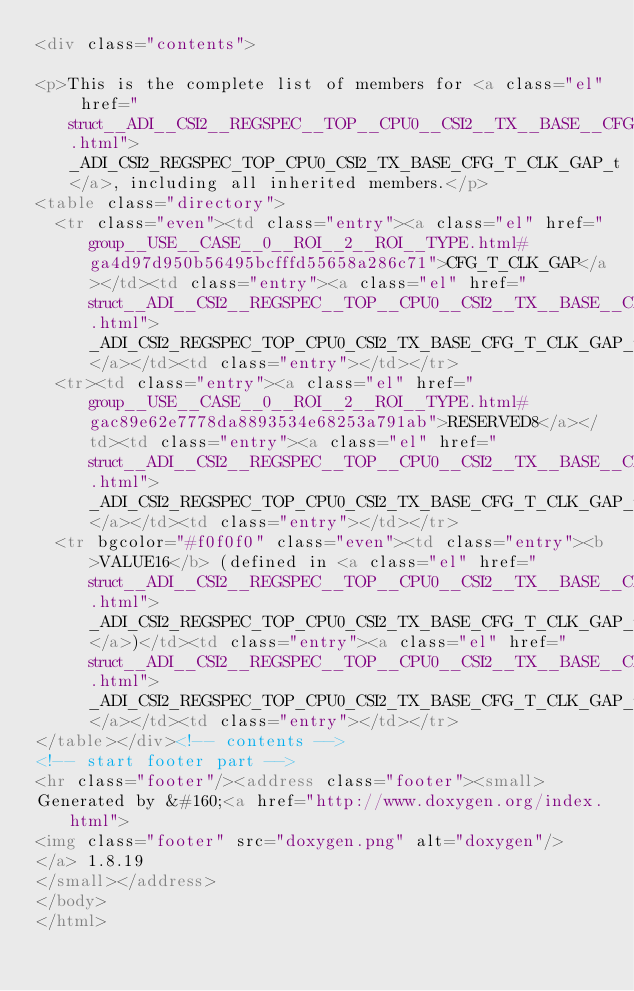Convert code to text. <code><loc_0><loc_0><loc_500><loc_500><_HTML_><div class="contents">

<p>This is the complete list of members for <a class="el" href="struct__ADI__CSI2__REGSPEC__TOP__CPU0__CSI2__TX__BASE__CFG__T__CLK__GAP__t.html">_ADI_CSI2_REGSPEC_TOP_CPU0_CSI2_TX_BASE_CFG_T_CLK_GAP_t</a>, including all inherited members.</p>
<table class="directory">
  <tr class="even"><td class="entry"><a class="el" href="group__USE__CASE__0__ROI__2__ROI__TYPE.html#ga4d97d950b56495bcfffd55658a286c71">CFG_T_CLK_GAP</a></td><td class="entry"><a class="el" href="struct__ADI__CSI2__REGSPEC__TOP__CPU0__CSI2__TX__BASE__CFG__T__CLK__GAP__t.html">_ADI_CSI2_REGSPEC_TOP_CPU0_CSI2_TX_BASE_CFG_T_CLK_GAP_t</a></td><td class="entry"></td></tr>
  <tr><td class="entry"><a class="el" href="group__USE__CASE__0__ROI__2__ROI__TYPE.html#gac89e62e7778da8893534e68253a791ab">RESERVED8</a></td><td class="entry"><a class="el" href="struct__ADI__CSI2__REGSPEC__TOP__CPU0__CSI2__TX__BASE__CFG__T__CLK__GAP__t.html">_ADI_CSI2_REGSPEC_TOP_CPU0_CSI2_TX_BASE_CFG_T_CLK_GAP_t</a></td><td class="entry"></td></tr>
  <tr bgcolor="#f0f0f0" class="even"><td class="entry"><b>VALUE16</b> (defined in <a class="el" href="struct__ADI__CSI2__REGSPEC__TOP__CPU0__CSI2__TX__BASE__CFG__T__CLK__GAP__t.html">_ADI_CSI2_REGSPEC_TOP_CPU0_CSI2_TX_BASE_CFG_T_CLK_GAP_t</a>)</td><td class="entry"><a class="el" href="struct__ADI__CSI2__REGSPEC__TOP__CPU0__CSI2__TX__BASE__CFG__T__CLK__GAP__t.html">_ADI_CSI2_REGSPEC_TOP_CPU0_CSI2_TX_BASE_CFG_T_CLK_GAP_t</a></td><td class="entry"></td></tr>
</table></div><!-- contents -->
<!-- start footer part -->
<hr class="footer"/><address class="footer"><small>
Generated by &#160;<a href="http://www.doxygen.org/index.html">
<img class="footer" src="doxygen.png" alt="doxygen"/>
</a> 1.8.19
</small></address>
</body>
</html>
</code> 